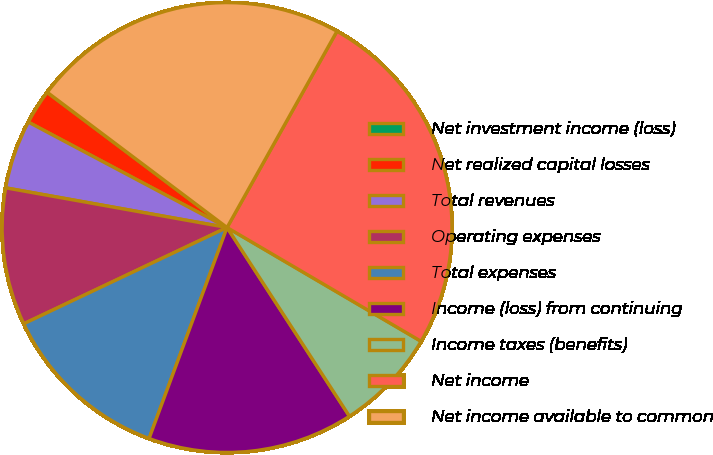Convert chart to OTSL. <chart><loc_0><loc_0><loc_500><loc_500><pie_chart><fcel>Net investment income (loss)<fcel>Net realized capital losses<fcel>Total revenues<fcel>Operating expenses<fcel>Total expenses<fcel>Income (loss) from continuing<fcel>Income taxes (benefits)<fcel>Net income<fcel>Net income available to common<nl><fcel>0.02%<fcel>2.48%<fcel>4.94%<fcel>9.86%<fcel>12.33%<fcel>14.79%<fcel>7.4%<fcel>25.32%<fcel>22.86%<nl></chart> 